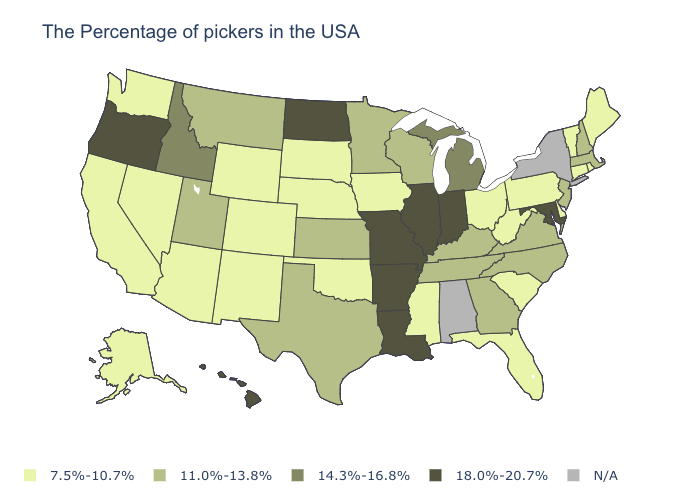What is the value of Iowa?
Concise answer only. 7.5%-10.7%. Name the states that have a value in the range N/A?
Write a very short answer. New York, Alabama. What is the value of Utah?
Short answer required. 11.0%-13.8%. What is the value of Alabama?
Quick response, please. N/A. Among the states that border Nebraska , does South Dakota have the highest value?
Be succinct. No. Does New Jersey have the lowest value in the USA?
Short answer required. No. Among the states that border Illinois , does Missouri have the lowest value?
Give a very brief answer. No. Name the states that have a value in the range 18.0%-20.7%?
Give a very brief answer. Maryland, Indiana, Illinois, Louisiana, Missouri, Arkansas, North Dakota, Oregon, Hawaii. What is the value of Virginia?
Quick response, please. 11.0%-13.8%. Name the states that have a value in the range 14.3%-16.8%?
Answer briefly. Michigan, Idaho. What is the highest value in the USA?
Keep it brief. 18.0%-20.7%. What is the value of Arkansas?
Be succinct. 18.0%-20.7%. Name the states that have a value in the range 11.0%-13.8%?
Answer briefly. Massachusetts, New Hampshire, New Jersey, Virginia, North Carolina, Georgia, Kentucky, Tennessee, Wisconsin, Minnesota, Kansas, Texas, Utah, Montana. Name the states that have a value in the range 18.0%-20.7%?
Write a very short answer. Maryland, Indiana, Illinois, Louisiana, Missouri, Arkansas, North Dakota, Oregon, Hawaii. 